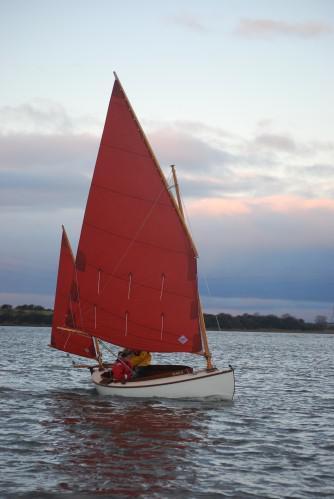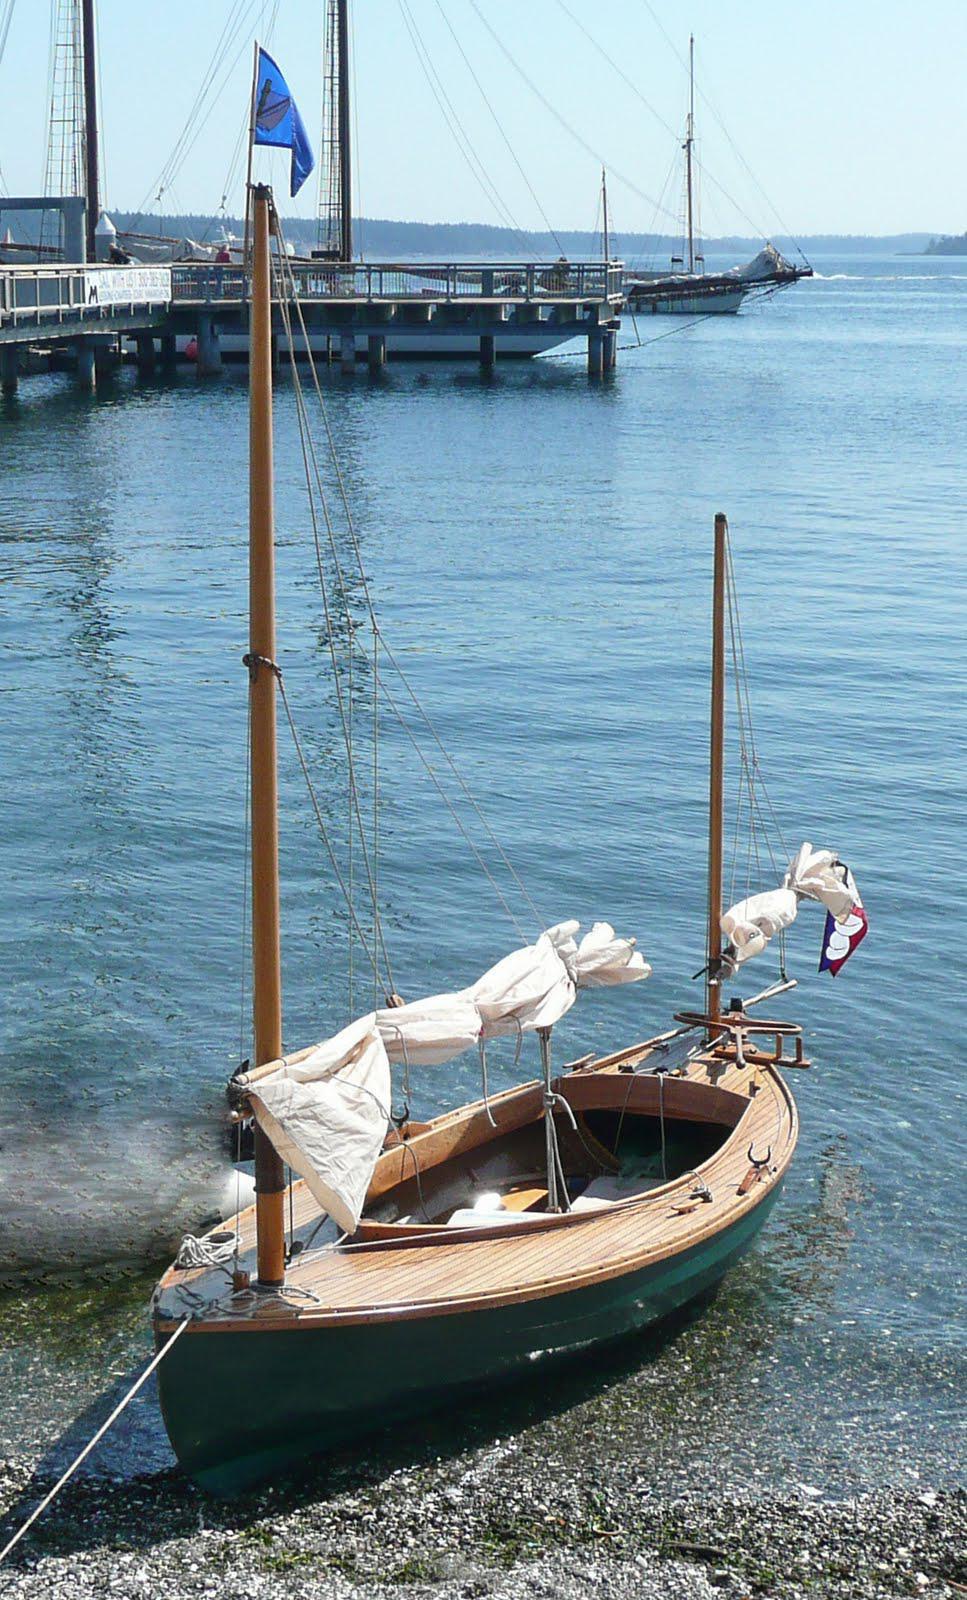The first image is the image on the left, the second image is the image on the right. Examine the images to the left and right. Is the description "The body of the boat in the image on the right is white." accurate? Answer yes or no. No. 